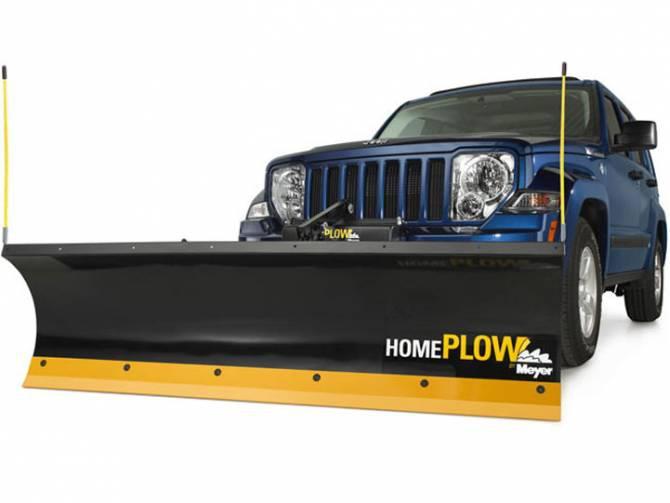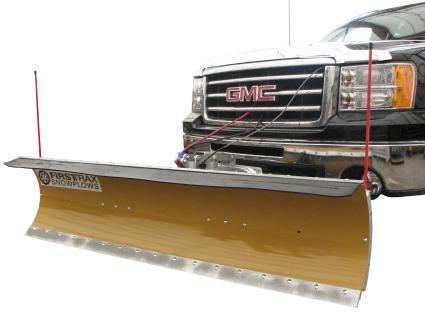The first image is the image on the left, the second image is the image on the right. Examine the images to the left and right. Is the description "One image shows an orange plow that is not attached to a vehicle." accurate? Answer yes or no. No. The first image is the image on the left, the second image is the image on the right. Given the left and right images, does the statement "One image shows a complete angled side view of a pickup truck with a front snow blade, while a second image shows an unattached orange snow blade." hold true? Answer yes or no. No. 